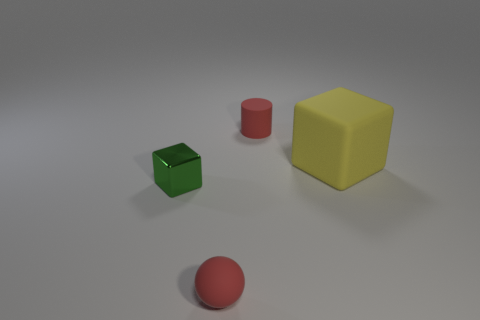Is there anything else that is the same size as the rubber cube?
Your answer should be compact. No. Is the shape of the tiny red object behind the small green block the same as  the metal object?
Make the answer very short. No. What shape is the small red thing that is in front of the small red rubber thing on the right side of the matte object that is in front of the yellow rubber thing?
Your answer should be compact. Sphere. There is a tiny red thing in front of the cylinder; what is its material?
Provide a short and direct response. Rubber. What color is the rubber cylinder that is the same size as the red ball?
Offer a terse response. Red. How many other objects are there of the same shape as the metal object?
Ensure brevity in your answer.  1. Does the green metal cube have the same size as the yellow block?
Keep it short and to the point. No. Is the number of red objects that are on the right side of the red rubber sphere greater than the number of red cylinders that are in front of the big rubber cube?
Ensure brevity in your answer.  Yes. How many other things are the same size as the yellow rubber object?
Offer a terse response. 0. There is a matte thing behind the yellow thing; does it have the same color as the matte ball?
Provide a short and direct response. Yes. 